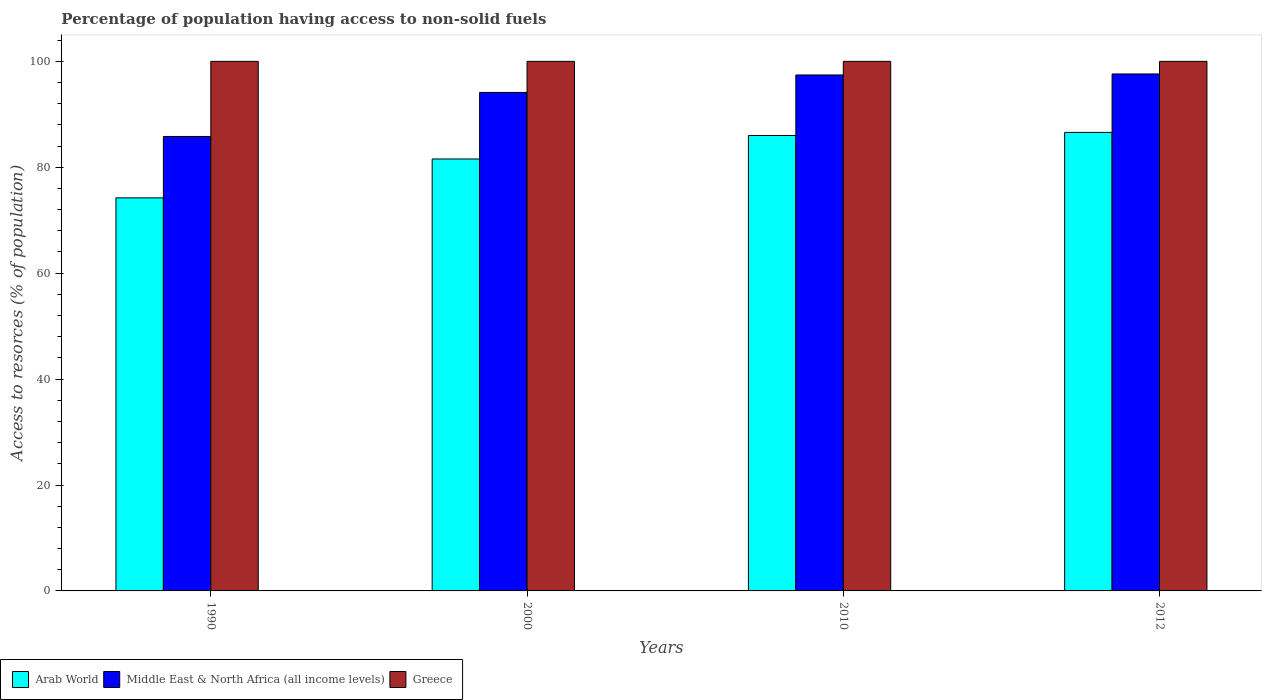Are the number of bars per tick equal to the number of legend labels?
Offer a terse response. Yes. Are the number of bars on each tick of the X-axis equal?
Make the answer very short. Yes. How many bars are there on the 1st tick from the left?
Ensure brevity in your answer.  3. How many bars are there on the 2nd tick from the right?
Provide a short and direct response. 3. What is the label of the 2nd group of bars from the left?
Make the answer very short. 2000. What is the percentage of population having access to non-solid fuels in Arab World in 1990?
Offer a very short reply. 74.22. Across all years, what is the maximum percentage of population having access to non-solid fuels in Middle East & North Africa (all income levels)?
Keep it short and to the point. 97.62. Across all years, what is the minimum percentage of population having access to non-solid fuels in Middle East & North Africa (all income levels)?
Keep it short and to the point. 85.81. In which year was the percentage of population having access to non-solid fuels in Middle East & North Africa (all income levels) maximum?
Offer a terse response. 2012. What is the total percentage of population having access to non-solid fuels in Arab World in the graph?
Make the answer very short. 328.38. What is the difference between the percentage of population having access to non-solid fuels in Middle East & North Africa (all income levels) in 2000 and that in 2010?
Provide a short and direct response. -3.3. What is the difference between the percentage of population having access to non-solid fuels in Arab World in 2000 and the percentage of population having access to non-solid fuels in Greece in 2010?
Keep it short and to the point. -18.43. What is the average percentage of population having access to non-solid fuels in Middle East & North Africa (all income levels) per year?
Offer a terse response. 93.75. In the year 1990, what is the difference between the percentage of population having access to non-solid fuels in Middle East & North Africa (all income levels) and percentage of population having access to non-solid fuels in Arab World?
Your answer should be compact. 11.59. What is the ratio of the percentage of population having access to non-solid fuels in Greece in 1990 to that in 2000?
Give a very brief answer. 1. Is the difference between the percentage of population having access to non-solid fuels in Middle East & North Africa (all income levels) in 2000 and 2010 greater than the difference between the percentage of population having access to non-solid fuels in Arab World in 2000 and 2010?
Provide a succinct answer. Yes. What is the difference between the highest and the second highest percentage of population having access to non-solid fuels in Middle East & North Africa (all income levels)?
Provide a succinct answer. 0.19. What does the 1st bar from the left in 2010 represents?
Offer a very short reply. Arab World. What does the 2nd bar from the right in 1990 represents?
Make the answer very short. Middle East & North Africa (all income levels). Are all the bars in the graph horizontal?
Keep it short and to the point. No. What is the difference between two consecutive major ticks on the Y-axis?
Offer a terse response. 20. Are the values on the major ticks of Y-axis written in scientific E-notation?
Keep it short and to the point. No. Does the graph contain grids?
Your answer should be very brief. No. What is the title of the graph?
Make the answer very short. Percentage of population having access to non-solid fuels. Does "Monaco" appear as one of the legend labels in the graph?
Provide a succinct answer. No. What is the label or title of the Y-axis?
Give a very brief answer. Access to resorces (% of population). What is the Access to resorces (% of population) in Arab World in 1990?
Make the answer very short. 74.22. What is the Access to resorces (% of population) of Middle East & North Africa (all income levels) in 1990?
Give a very brief answer. 85.81. What is the Access to resorces (% of population) in Greece in 1990?
Give a very brief answer. 100. What is the Access to resorces (% of population) in Arab World in 2000?
Provide a short and direct response. 81.57. What is the Access to resorces (% of population) of Middle East & North Africa (all income levels) in 2000?
Provide a short and direct response. 94.13. What is the Access to resorces (% of population) of Arab World in 2010?
Offer a terse response. 86. What is the Access to resorces (% of population) in Middle East & North Africa (all income levels) in 2010?
Keep it short and to the point. 97.43. What is the Access to resorces (% of population) of Arab World in 2012?
Provide a short and direct response. 86.59. What is the Access to resorces (% of population) in Middle East & North Africa (all income levels) in 2012?
Keep it short and to the point. 97.62. What is the Access to resorces (% of population) in Greece in 2012?
Your answer should be compact. 100. Across all years, what is the maximum Access to resorces (% of population) of Arab World?
Ensure brevity in your answer.  86.59. Across all years, what is the maximum Access to resorces (% of population) of Middle East & North Africa (all income levels)?
Your response must be concise. 97.62. Across all years, what is the maximum Access to resorces (% of population) in Greece?
Ensure brevity in your answer.  100. Across all years, what is the minimum Access to resorces (% of population) in Arab World?
Ensure brevity in your answer.  74.22. Across all years, what is the minimum Access to resorces (% of population) of Middle East & North Africa (all income levels)?
Make the answer very short. 85.81. What is the total Access to resorces (% of population) of Arab World in the graph?
Offer a terse response. 328.38. What is the total Access to resorces (% of population) of Middle East & North Africa (all income levels) in the graph?
Ensure brevity in your answer.  374.99. What is the difference between the Access to resorces (% of population) in Arab World in 1990 and that in 2000?
Offer a terse response. -7.34. What is the difference between the Access to resorces (% of population) in Middle East & North Africa (all income levels) in 1990 and that in 2000?
Ensure brevity in your answer.  -8.32. What is the difference between the Access to resorces (% of population) of Greece in 1990 and that in 2000?
Your answer should be compact. 0. What is the difference between the Access to resorces (% of population) of Arab World in 1990 and that in 2010?
Give a very brief answer. -11.78. What is the difference between the Access to resorces (% of population) in Middle East & North Africa (all income levels) in 1990 and that in 2010?
Provide a short and direct response. -11.61. What is the difference between the Access to resorces (% of population) of Greece in 1990 and that in 2010?
Make the answer very short. 0. What is the difference between the Access to resorces (% of population) in Arab World in 1990 and that in 2012?
Ensure brevity in your answer.  -12.36. What is the difference between the Access to resorces (% of population) in Middle East & North Africa (all income levels) in 1990 and that in 2012?
Ensure brevity in your answer.  -11.8. What is the difference between the Access to resorces (% of population) in Arab World in 2000 and that in 2010?
Your answer should be very brief. -4.44. What is the difference between the Access to resorces (% of population) of Middle East & North Africa (all income levels) in 2000 and that in 2010?
Your answer should be compact. -3.3. What is the difference between the Access to resorces (% of population) in Greece in 2000 and that in 2010?
Offer a terse response. 0. What is the difference between the Access to resorces (% of population) of Arab World in 2000 and that in 2012?
Provide a short and direct response. -5.02. What is the difference between the Access to resorces (% of population) in Middle East & North Africa (all income levels) in 2000 and that in 2012?
Keep it short and to the point. -3.49. What is the difference between the Access to resorces (% of population) in Arab World in 2010 and that in 2012?
Your response must be concise. -0.58. What is the difference between the Access to resorces (% of population) in Middle East & North Africa (all income levels) in 2010 and that in 2012?
Ensure brevity in your answer.  -0.19. What is the difference between the Access to resorces (% of population) in Arab World in 1990 and the Access to resorces (% of population) in Middle East & North Africa (all income levels) in 2000?
Your answer should be compact. -19.91. What is the difference between the Access to resorces (% of population) of Arab World in 1990 and the Access to resorces (% of population) of Greece in 2000?
Ensure brevity in your answer.  -25.78. What is the difference between the Access to resorces (% of population) in Middle East & North Africa (all income levels) in 1990 and the Access to resorces (% of population) in Greece in 2000?
Keep it short and to the point. -14.19. What is the difference between the Access to resorces (% of population) of Arab World in 1990 and the Access to resorces (% of population) of Middle East & North Africa (all income levels) in 2010?
Give a very brief answer. -23.2. What is the difference between the Access to resorces (% of population) of Arab World in 1990 and the Access to resorces (% of population) of Greece in 2010?
Make the answer very short. -25.78. What is the difference between the Access to resorces (% of population) in Middle East & North Africa (all income levels) in 1990 and the Access to resorces (% of population) in Greece in 2010?
Your response must be concise. -14.19. What is the difference between the Access to resorces (% of population) in Arab World in 1990 and the Access to resorces (% of population) in Middle East & North Africa (all income levels) in 2012?
Provide a succinct answer. -23.39. What is the difference between the Access to resorces (% of population) of Arab World in 1990 and the Access to resorces (% of population) of Greece in 2012?
Give a very brief answer. -25.78. What is the difference between the Access to resorces (% of population) of Middle East & North Africa (all income levels) in 1990 and the Access to resorces (% of population) of Greece in 2012?
Your answer should be compact. -14.19. What is the difference between the Access to resorces (% of population) in Arab World in 2000 and the Access to resorces (% of population) in Middle East & North Africa (all income levels) in 2010?
Offer a terse response. -15.86. What is the difference between the Access to resorces (% of population) in Arab World in 2000 and the Access to resorces (% of population) in Greece in 2010?
Keep it short and to the point. -18.43. What is the difference between the Access to resorces (% of population) of Middle East & North Africa (all income levels) in 2000 and the Access to resorces (% of population) of Greece in 2010?
Offer a terse response. -5.87. What is the difference between the Access to resorces (% of population) in Arab World in 2000 and the Access to resorces (% of population) in Middle East & North Africa (all income levels) in 2012?
Keep it short and to the point. -16.05. What is the difference between the Access to resorces (% of population) in Arab World in 2000 and the Access to resorces (% of population) in Greece in 2012?
Provide a short and direct response. -18.43. What is the difference between the Access to resorces (% of population) of Middle East & North Africa (all income levels) in 2000 and the Access to resorces (% of population) of Greece in 2012?
Make the answer very short. -5.87. What is the difference between the Access to resorces (% of population) in Arab World in 2010 and the Access to resorces (% of population) in Middle East & North Africa (all income levels) in 2012?
Make the answer very short. -11.61. What is the difference between the Access to resorces (% of population) of Arab World in 2010 and the Access to resorces (% of population) of Greece in 2012?
Provide a succinct answer. -14. What is the difference between the Access to resorces (% of population) in Middle East & North Africa (all income levels) in 2010 and the Access to resorces (% of population) in Greece in 2012?
Ensure brevity in your answer.  -2.57. What is the average Access to resorces (% of population) of Arab World per year?
Ensure brevity in your answer.  82.09. What is the average Access to resorces (% of population) of Middle East & North Africa (all income levels) per year?
Provide a short and direct response. 93.75. In the year 1990, what is the difference between the Access to resorces (% of population) of Arab World and Access to resorces (% of population) of Middle East & North Africa (all income levels)?
Provide a succinct answer. -11.59. In the year 1990, what is the difference between the Access to resorces (% of population) of Arab World and Access to resorces (% of population) of Greece?
Make the answer very short. -25.78. In the year 1990, what is the difference between the Access to resorces (% of population) in Middle East & North Africa (all income levels) and Access to resorces (% of population) in Greece?
Your answer should be compact. -14.19. In the year 2000, what is the difference between the Access to resorces (% of population) of Arab World and Access to resorces (% of population) of Middle East & North Africa (all income levels)?
Keep it short and to the point. -12.57. In the year 2000, what is the difference between the Access to resorces (% of population) of Arab World and Access to resorces (% of population) of Greece?
Make the answer very short. -18.43. In the year 2000, what is the difference between the Access to resorces (% of population) in Middle East & North Africa (all income levels) and Access to resorces (% of population) in Greece?
Give a very brief answer. -5.87. In the year 2010, what is the difference between the Access to resorces (% of population) in Arab World and Access to resorces (% of population) in Middle East & North Africa (all income levels)?
Offer a very short reply. -11.42. In the year 2010, what is the difference between the Access to resorces (% of population) in Arab World and Access to resorces (% of population) in Greece?
Keep it short and to the point. -14. In the year 2010, what is the difference between the Access to resorces (% of population) in Middle East & North Africa (all income levels) and Access to resorces (% of population) in Greece?
Give a very brief answer. -2.57. In the year 2012, what is the difference between the Access to resorces (% of population) of Arab World and Access to resorces (% of population) of Middle East & North Africa (all income levels)?
Offer a very short reply. -11.03. In the year 2012, what is the difference between the Access to resorces (% of population) of Arab World and Access to resorces (% of population) of Greece?
Your answer should be compact. -13.41. In the year 2012, what is the difference between the Access to resorces (% of population) of Middle East & North Africa (all income levels) and Access to resorces (% of population) of Greece?
Your answer should be compact. -2.38. What is the ratio of the Access to resorces (% of population) in Arab World in 1990 to that in 2000?
Ensure brevity in your answer.  0.91. What is the ratio of the Access to resorces (% of population) of Middle East & North Africa (all income levels) in 1990 to that in 2000?
Your answer should be very brief. 0.91. What is the ratio of the Access to resorces (% of population) in Greece in 1990 to that in 2000?
Your response must be concise. 1. What is the ratio of the Access to resorces (% of population) in Arab World in 1990 to that in 2010?
Provide a short and direct response. 0.86. What is the ratio of the Access to resorces (% of population) of Middle East & North Africa (all income levels) in 1990 to that in 2010?
Provide a succinct answer. 0.88. What is the ratio of the Access to resorces (% of population) of Greece in 1990 to that in 2010?
Offer a terse response. 1. What is the ratio of the Access to resorces (% of population) in Arab World in 1990 to that in 2012?
Provide a short and direct response. 0.86. What is the ratio of the Access to resorces (% of population) in Middle East & North Africa (all income levels) in 1990 to that in 2012?
Ensure brevity in your answer.  0.88. What is the ratio of the Access to resorces (% of population) of Greece in 1990 to that in 2012?
Offer a terse response. 1. What is the ratio of the Access to resorces (% of population) of Arab World in 2000 to that in 2010?
Offer a very short reply. 0.95. What is the ratio of the Access to resorces (% of population) in Middle East & North Africa (all income levels) in 2000 to that in 2010?
Your answer should be compact. 0.97. What is the ratio of the Access to resorces (% of population) of Arab World in 2000 to that in 2012?
Ensure brevity in your answer.  0.94. What is the ratio of the Access to resorces (% of population) of Middle East & North Africa (all income levels) in 2000 to that in 2012?
Give a very brief answer. 0.96. What is the ratio of the Access to resorces (% of population) in Greece in 2000 to that in 2012?
Your answer should be compact. 1. What is the ratio of the Access to resorces (% of population) in Arab World in 2010 to that in 2012?
Offer a very short reply. 0.99. What is the difference between the highest and the second highest Access to resorces (% of population) in Arab World?
Provide a short and direct response. 0.58. What is the difference between the highest and the second highest Access to resorces (% of population) of Middle East & North Africa (all income levels)?
Your answer should be very brief. 0.19. What is the difference between the highest and the second highest Access to resorces (% of population) of Greece?
Provide a short and direct response. 0. What is the difference between the highest and the lowest Access to resorces (% of population) of Arab World?
Offer a very short reply. 12.36. What is the difference between the highest and the lowest Access to resorces (% of population) in Middle East & North Africa (all income levels)?
Your answer should be compact. 11.8. What is the difference between the highest and the lowest Access to resorces (% of population) of Greece?
Give a very brief answer. 0. 